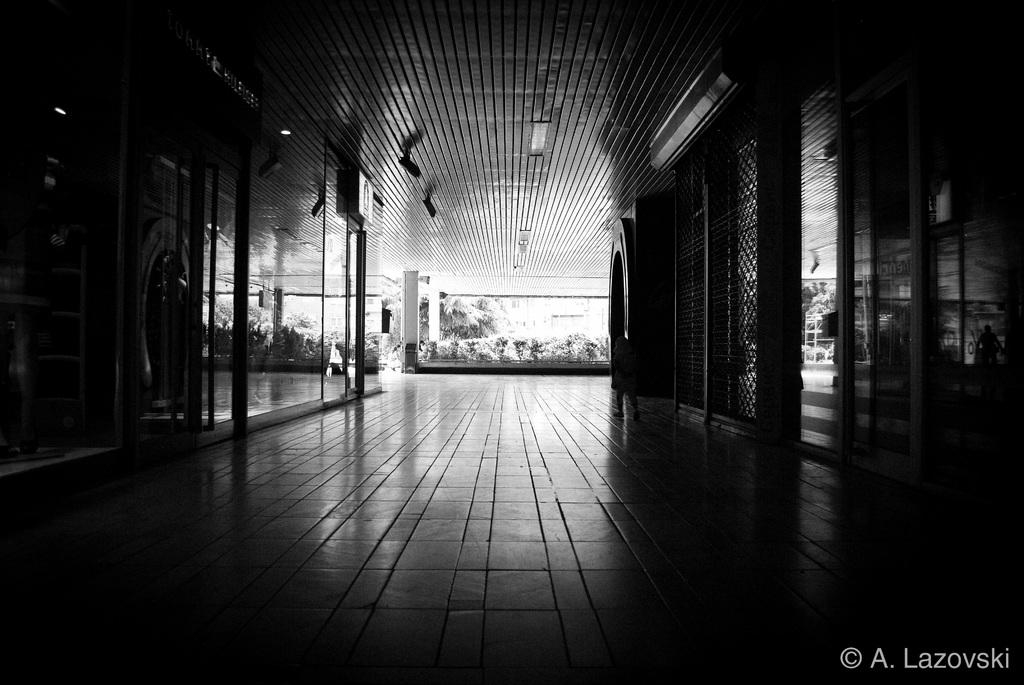What type of location is depicted in the image? The image shows an inside view of a building. What can be seen in the middle of the image? There are plants in the middle of the image. What scientific experience can be observed in the image? There is no specific scientific experience depicted in the image; it simply shows an inside view of a building with plants in the middle. 